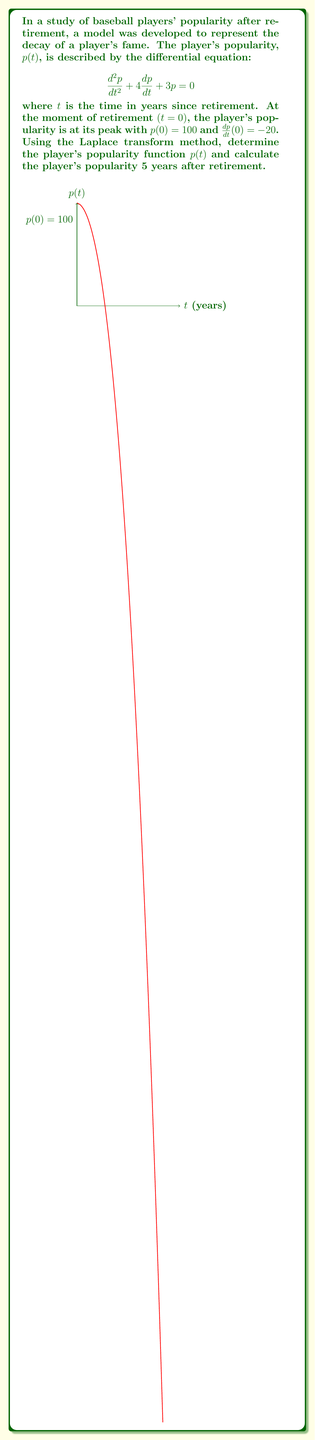Provide a solution to this math problem. Let's solve this problem step by step using the Laplace transform method:

1) First, we take the Laplace transform of both sides of the differential equation:
   $$\mathcal{L}\{p''(t) + 4p'(t) + 3p(t)\} = \mathcal{L}\{0\}$$

2) Using the properties of Laplace transforms:
   $$(s^2P(s) - sp(0) - p'(0)) + 4(sP(s) - p(0)) + 3P(s) = 0$$

3) Substitute the initial conditions $p(0) = 100$ and $p'(0) = -20$:
   $$(s^2P(s) - 100s + 20) + 4(sP(s) - 100) + 3P(s) = 0$$

4) Simplify:
   $$s^2P(s) + 4sP(s) + 3P(s) = 100s + 380$$
   $$(s^2 + 4s + 3)P(s) = 100s + 380$$

5) Solve for $P(s)$:
   $$P(s) = \frac{100s + 380}{s^2 + 4s + 3} = \frac{100s + 380}{(s+1)(s+3)}$$

6) Perform partial fraction decomposition:
   $$P(s) = \frac{A}{s+1} + \frac{B}{s+3}$$
   
   Solving for A and B:
   $$A = 120, B = -20$$

   $$P(s) = \frac{120}{s+1} - \frac{20}{s+3}$$

7) Take the inverse Laplace transform:
   $$p(t) = 120e^{-t} - 20e^{-3t}$$

8) To find the popularity after 5 years, substitute $t=5$:
   $$p(5) = 120e^{-5} - 20e^{-15} \approx 0.8019$$

Therefore, the player's popularity function is $p(t) = 120e^{-t} - 20e^{-3t}$, and their popularity 5 years after retirement is approximately 0.8019 (on a scale where 100 was the peak popularity).
Answer: $p(t) = 120e^{-t} - 20e^{-3t}$; $p(5) \approx 0.8019$ 